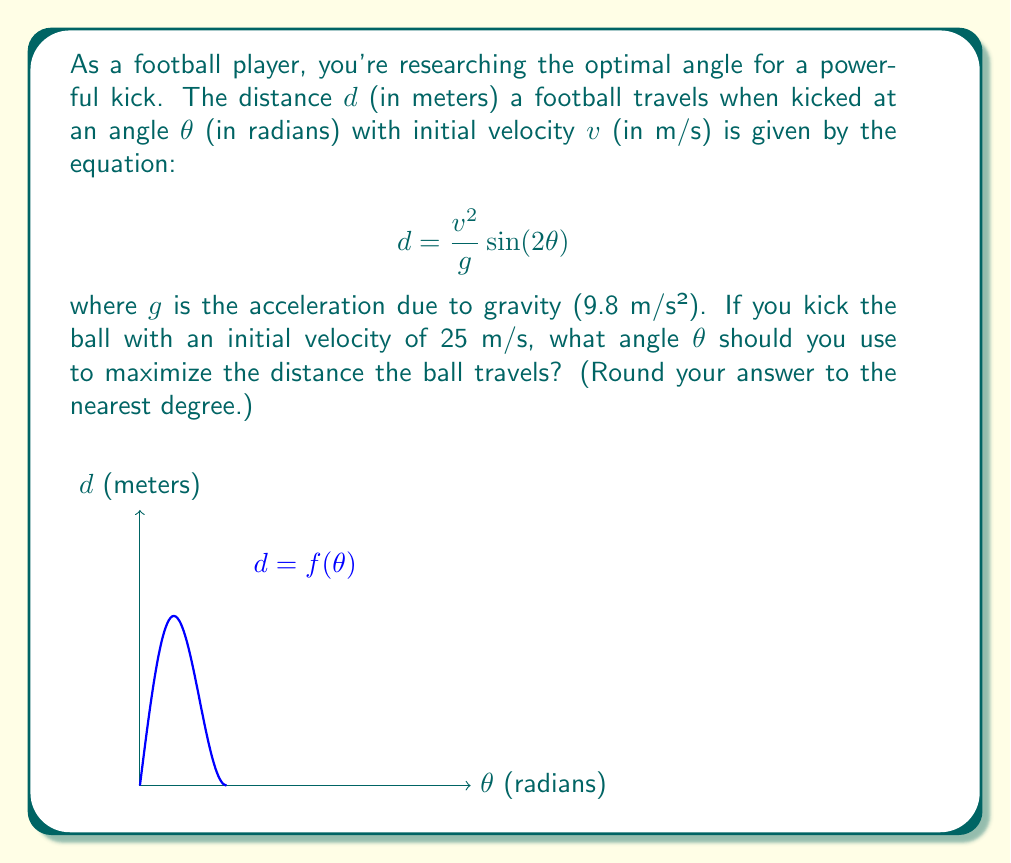Help me with this question. To find the optimal angle, we need to maximize the function $d(\theta)$. We can do this by finding where its derivative equals zero.

1) First, let's simplify the equation by substituting the known values:
   $$d = \frac{25^2}{9.8} \sin(2\theta) \approx 63.78 \sin(2\theta)$$

2) Now, we need to find $\frac{dd}{d\theta}$ and set it equal to zero:
   $$\frac{dd}{d\theta} = 63.78 \cdot 2\cos(2\theta) = 127.56\cos(2\theta)$$

3) Set this equal to zero and solve for $\theta$:
   $$127.56\cos(2\theta) = 0$$
   $$\cos(2\theta) = 0$$

4) The cosine function equals zero when its argument is $\frac{\pi}{2}$ or $\frac{3\pi}{2}$. So:
   $$2\theta = \frac{\pi}{2}$$
   $$\theta = \frac{\pi}{4} \approx 0.7854 \text{ radians}$$

5) Convert to degrees:
   $$\theta \approx 0.7854 \cdot \frac{180}{\pi} \approx 45°$$

6) To confirm this is a maximum (not a minimum), we can check the second derivative:
   $$\frac{d^2d}{d\theta^2} = -127.56 \cdot 2\sin(2\theta)$$
   At $\theta = \frac{\pi}{4}$, this is negative, confirming a maximum.

Therefore, the optimal angle to maximize the distance is 45°.
Answer: 45° 